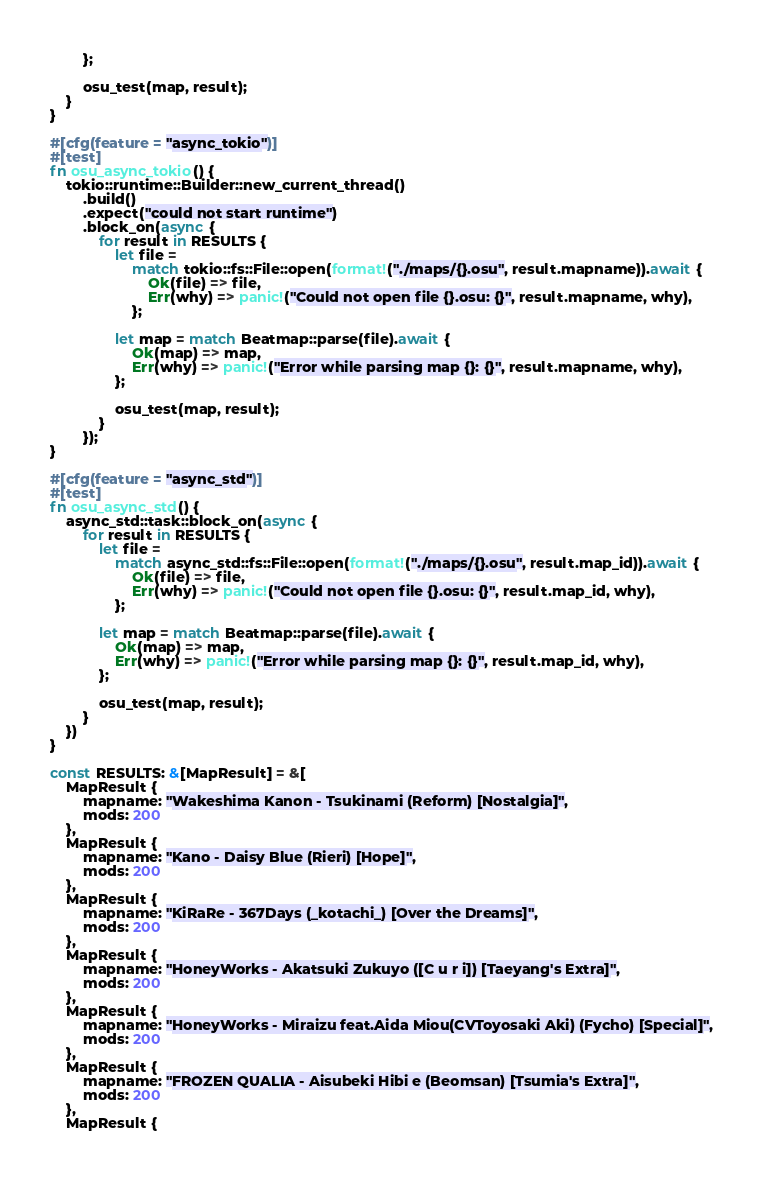Convert code to text. <code><loc_0><loc_0><loc_500><loc_500><_Rust_>        };

        osu_test(map, result);
    }
}

#[cfg(feature = "async_tokio")]
#[test]
fn osu_async_tokio() {
    tokio::runtime::Builder::new_current_thread()
        .build()
        .expect("could not start runtime")
        .block_on(async {
            for result in RESULTS {
                let file =
                    match tokio::fs::File::open(format!("./maps/{}.osu", result.mapname)).await {
                        Ok(file) => file,
                        Err(why) => panic!("Could not open file {}.osu: {}", result.mapname, why),
                    };

                let map = match Beatmap::parse(file).await {
                    Ok(map) => map,
                    Err(why) => panic!("Error while parsing map {}: {}", result.mapname, why),
                };

                osu_test(map, result);
            }
        });
}

#[cfg(feature = "async_std")]
#[test]
fn osu_async_std() {
    async_std::task::block_on(async {
        for result in RESULTS {
            let file =
                match async_std::fs::File::open(format!("./maps/{}.osu", result.map_id)).await {
                    Ok(file) => file,
                    Err(why) => panic!("Could not open file {}.osu: {}", result.map_id, why),
                };

            let map = match Beatmap::parse(file).await {
                Ok(map) => map,
                Err(why) => panic!("Error while parsing map {}: {}", result.map_id, why),
            };

            osu_test(map, result);
        }
    })
}

const RESULTS: &[MapResult] = &[
    MapResult {
        mapname: "Wakeshima Kanon - Tsukinami (Reform) [Nostalgia]",
        mods: 200
    },
    MapResult {
        mapname: "Kano - Daisy Blue (Rieri) [Hope]",
        mods: 200
    },
    MapResult {
        mapname: "KiRaRe - 367Days (_kotachi_) [Over the Dreams]",
        mods: 200
    },
    MapResult {
        mapname: "HoneyWorks - Akatsuki Zukuyo ([C u r i]) [Taeyang's Extra]",
        mods: 200
    },
    MapResult {
        mapname: "HoneyWorks - Miraizu feat.Aida Miou(CVToyosaki Aki) (Fycho) [Special]",
        mods: 200
    },
    MapResult {
        mapname: "FROZEN QUALIA - Aisubeki Hibi e (Beomsan) [Tsumia's Extra]",
        mods: 200
    },
    MapResult {</code> 